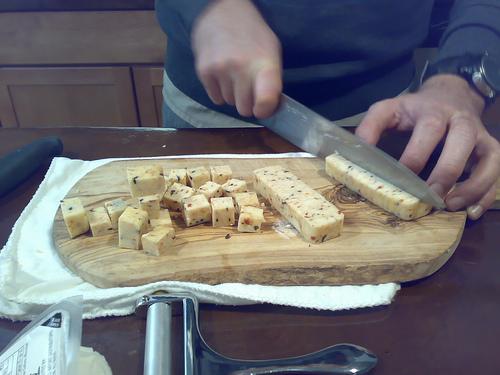What kind of cheese is it?
Concise answer only. Pepper jack. What kind of food is this?
Keep it brief. Cheese. What is the person wearing on his wrist?
Concise answer only. Watch. 